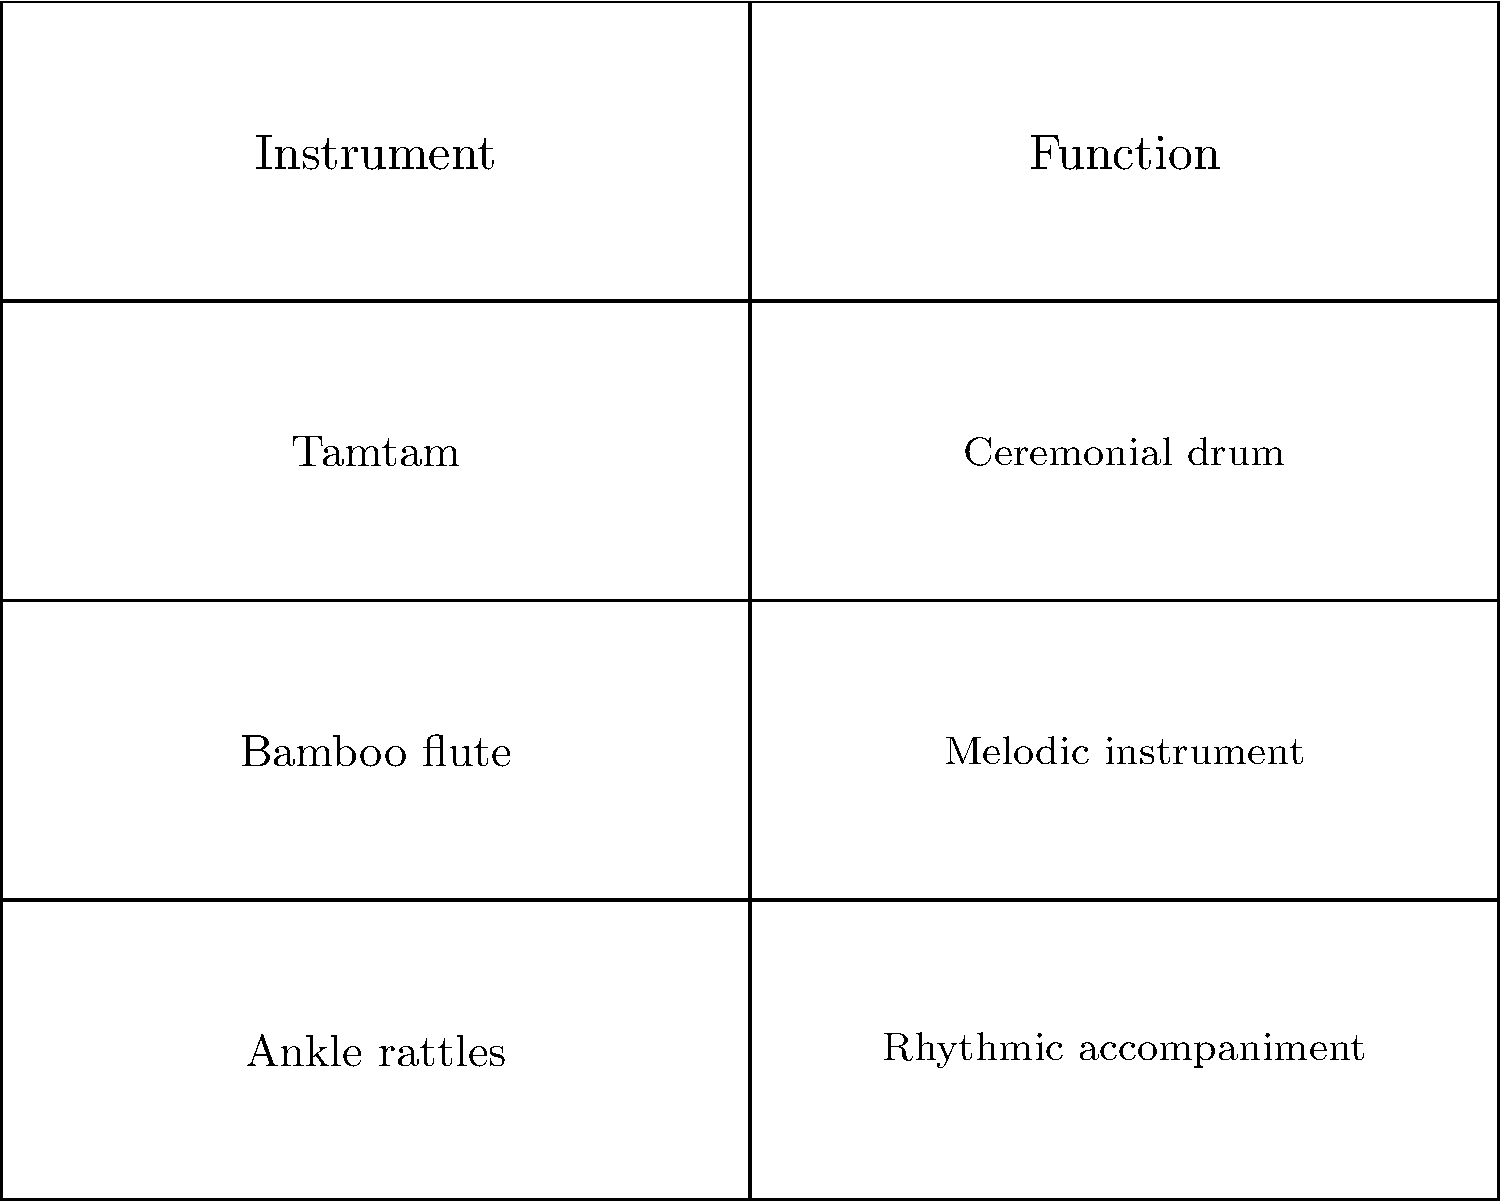Match the Vanuatu musical instruments to their correct functions based on the information provided in the table. To match the Vanuatu musical instruments to their correct functions, let's analyze each instrument and its corresponding function:

1. Tamtam:
   - This is a traditional wooden slit drum used in Vanuatu.
   - Its primary function is as a ceremonial drum, used in various rituals and important events.

2. Bamboo flute:
   - This instrument is made from bamboo and is played by blowing across a hole.
   - Its function is as a melodic instrument, capable of producing different notes and tunes.

3. Ankle rattles:
   - These are percussion instruments worn around the ankles.
   - Their function is to provide rhythmic accompaniment, especially during dances and performances.

By matching each instrument to its corresponding function, we can correctly pair them as follows:
- Tamtam: Ceremonial drum
- Bamboo flute: Melodic instrument
- Ankle rattles: Rhythmic accompaniment
Answer: Tamtam: Ceremonial drum; Bamboo flute: Melodic instrument; Ankle rattles: Rhythmic accompaniment 